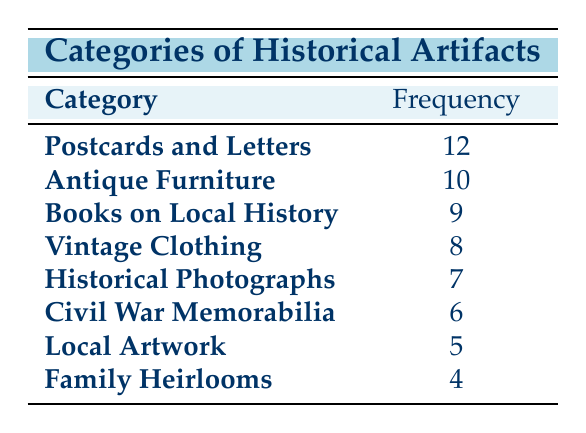What is the category with the highest frequency? The category that has the highest frequency can be found by looking through the frequencies of all the categories listed in the table. The highest frequency in the table is 12, which corresponds to the category "Postcards and Letters."
Answer: Postcards and Letters How many categories have a frequency of 6 or more? To answer this, we need to count all the categories that have frequencies of 6 or higher. By inspecting the table, we see the following categories: "Postcards and Letters" (12), "Antique Furniture" (10), "Books on Local History" (9), "Vintage Clothing" (8), "Historical Photographs" (7), and "Civil War Memorabilia" (6). This gives us a total of 6 categories.
Answer: 6 Is "Family Heirlooms" the only category with a frequency less than 5? We carefully check the category "Family Heirlooms," which has a frequency of 4. We then review the other categories and see that "Local Artwork" has a frequency of 5 and all others have a frequency higher than 4. Thus, "Family Heirlooms" is the only category with a frequency less than 5.
Answer: Yes What is the sum of the frequencies for "Vintage Clothing" and "Civil War Memorabilia"? To find the sum, we look at the frequencies for each of the selected categories. The frequency of "Vintage Clothing" is 8 and for "Civil War Memorabilia" is 6. We then add these two frequencies together: 8 + 6 = 14.
Answer: 14 What is the average frequency of the artifact categories listed? To find the average frequency, we first need to sum all the frequencies from the table. The frequencies are: 12 (Postcards and Letters), 10 (Antique Furniture), 9 (Books on Local History), 8 (Vintage Clothing), 7 (Historical Photographs), 6 (Civil War Memorabilia), 5 (Local Artwork), and 4 (Family Heirlooms). Adding these gives us: 12 + 10 + 9 + 8 + 7 + 6 + 5 + 4 = 61. There are 8 categories, so we divide the total frequency by the number of categories: 61 / 8 = 7.625.
Answer: 7.625 